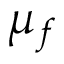Convert formula to latex. <formula><loc_0><loc_0><loc_500><loc_500>\mu _ { f }</formula> 